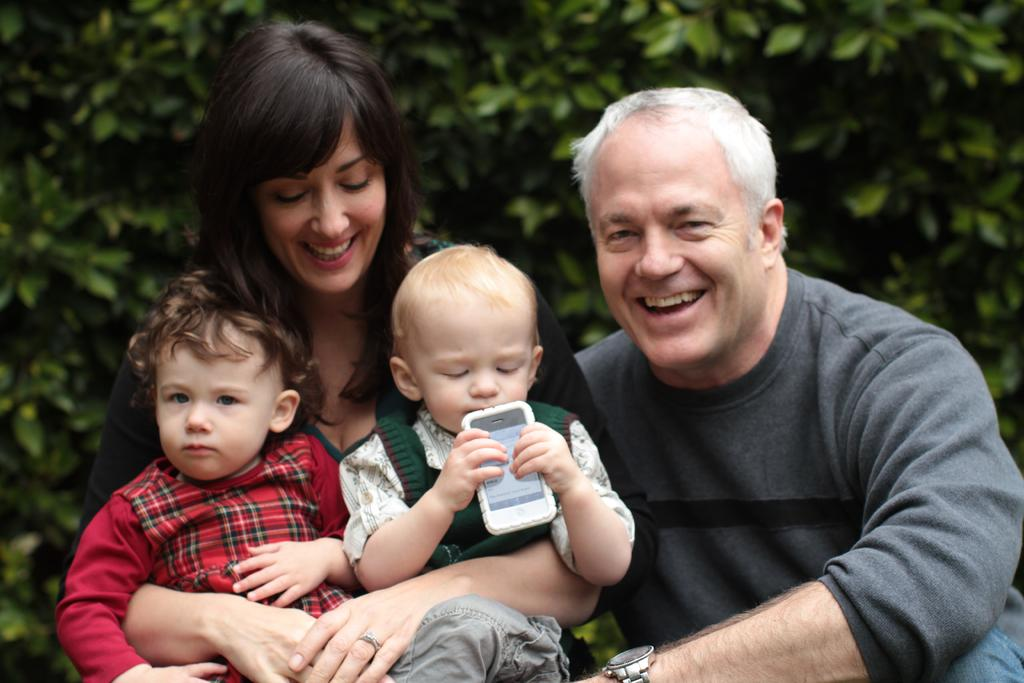How many people are present in the image? There are two people in the image, a man and a woman. What are the expressions of the people in the image? Both the man and the woman are smiling in the image. What is the woman holding in the image? The woman is holding two kids in the image. What can be seen in the background of the image? There are trees in the background of the image. What type of mist can be seen surrounding the moon in the image? There is no mist or moon present in the image; it features a man, a woman, and two kids with trees in the background. What color is the woman's eye in the image? The color of the woman's eye cannot be determined from the image, as it is not visible or mentioned in the provided facts. 